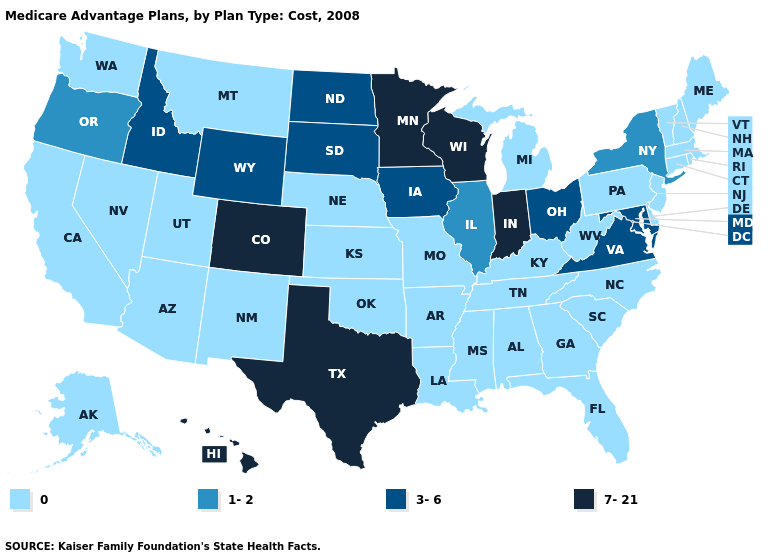Does Kentucky have the same value as Iowa?
Give a very brief answer. No. What is the highest value in the USA?
Quick response, please. 7-21. What is the highest value in the Northeast ?
Write a very short answer. 1-2. Does Utah have a lower value than Kentucky?
Answer briefly. No. What is the highest value in states that border Massachusetts?
Keep it brief. 1-2. Does the map have missing data?
Short answer required. No. What is the value of Nebraska?
Give a very brief answer. 0. Which states hav the highest value in the South?
Keep it brief. Texas. What is the highest value in states that border North Carolina?
Quick response, please. 3-6. What is the value of Illinois?
Short answer required. 1-2. Name the states that have a value in the range 1-2?
Concise answer only. Illinois, New York, Oregon. Name the states that have a value in the range 0?
Short answer required. Alaska, Alabama, Arkansas, Arizona, California, Connecticut, Delaware, Florida, Georgia, Kansas, Kentucky, Louisiana, Massachusetts, Maine, Michigan, Missouri, Mississippi, Montana, North Carolina, Nebraska, New Hampshire, New Jersey, New Mexico, Nevada, Oklahoma, Pennsylvania, Rhode Island, South Carolina, Tennessee, Utah, Vermont, Washington, West Virginia. Name the states that have a value in the range 3-6?
Write a very short answer. Iowa, Idaho, Maryland, North Dakota, Ohio, South Dakota, Virginia, Wyoming. How many symbols are there in the legend?
Give a very brief answer. 4. What is the lowest value in the West?
Short answer required. 0. 